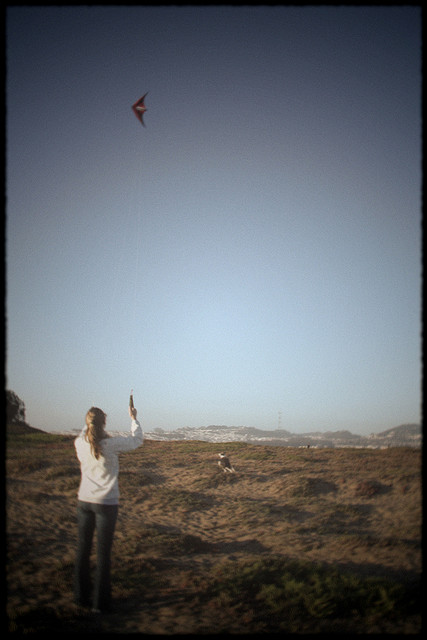<image>What the person wearing visor? It is uncertain whether the person is wearing a visor or not. What sport is the man playing? I can not confirm the man is playing a particular sport. The answer might be kite flying. What is not allowed? It is ambiguous to specify what is not allowed without the corresponding image. Which animal is live? It is ambiguous to know which animal is live. It can be a dog, a human, or a bird. What the person wearing visor? The person is not wearing a visor. What sport is the man playing? I am not sure what sport the man is playing. It can be seen 'kite flying' or 'kiting'. What is not allowed? I don't know what is not allowed. It can be dogs, littering, trespassing, flying, kite flying, or biking. But it can also be nothing. Which animal is live? It is not clear which animal is live. It can be seen a dog, human, or bird. 